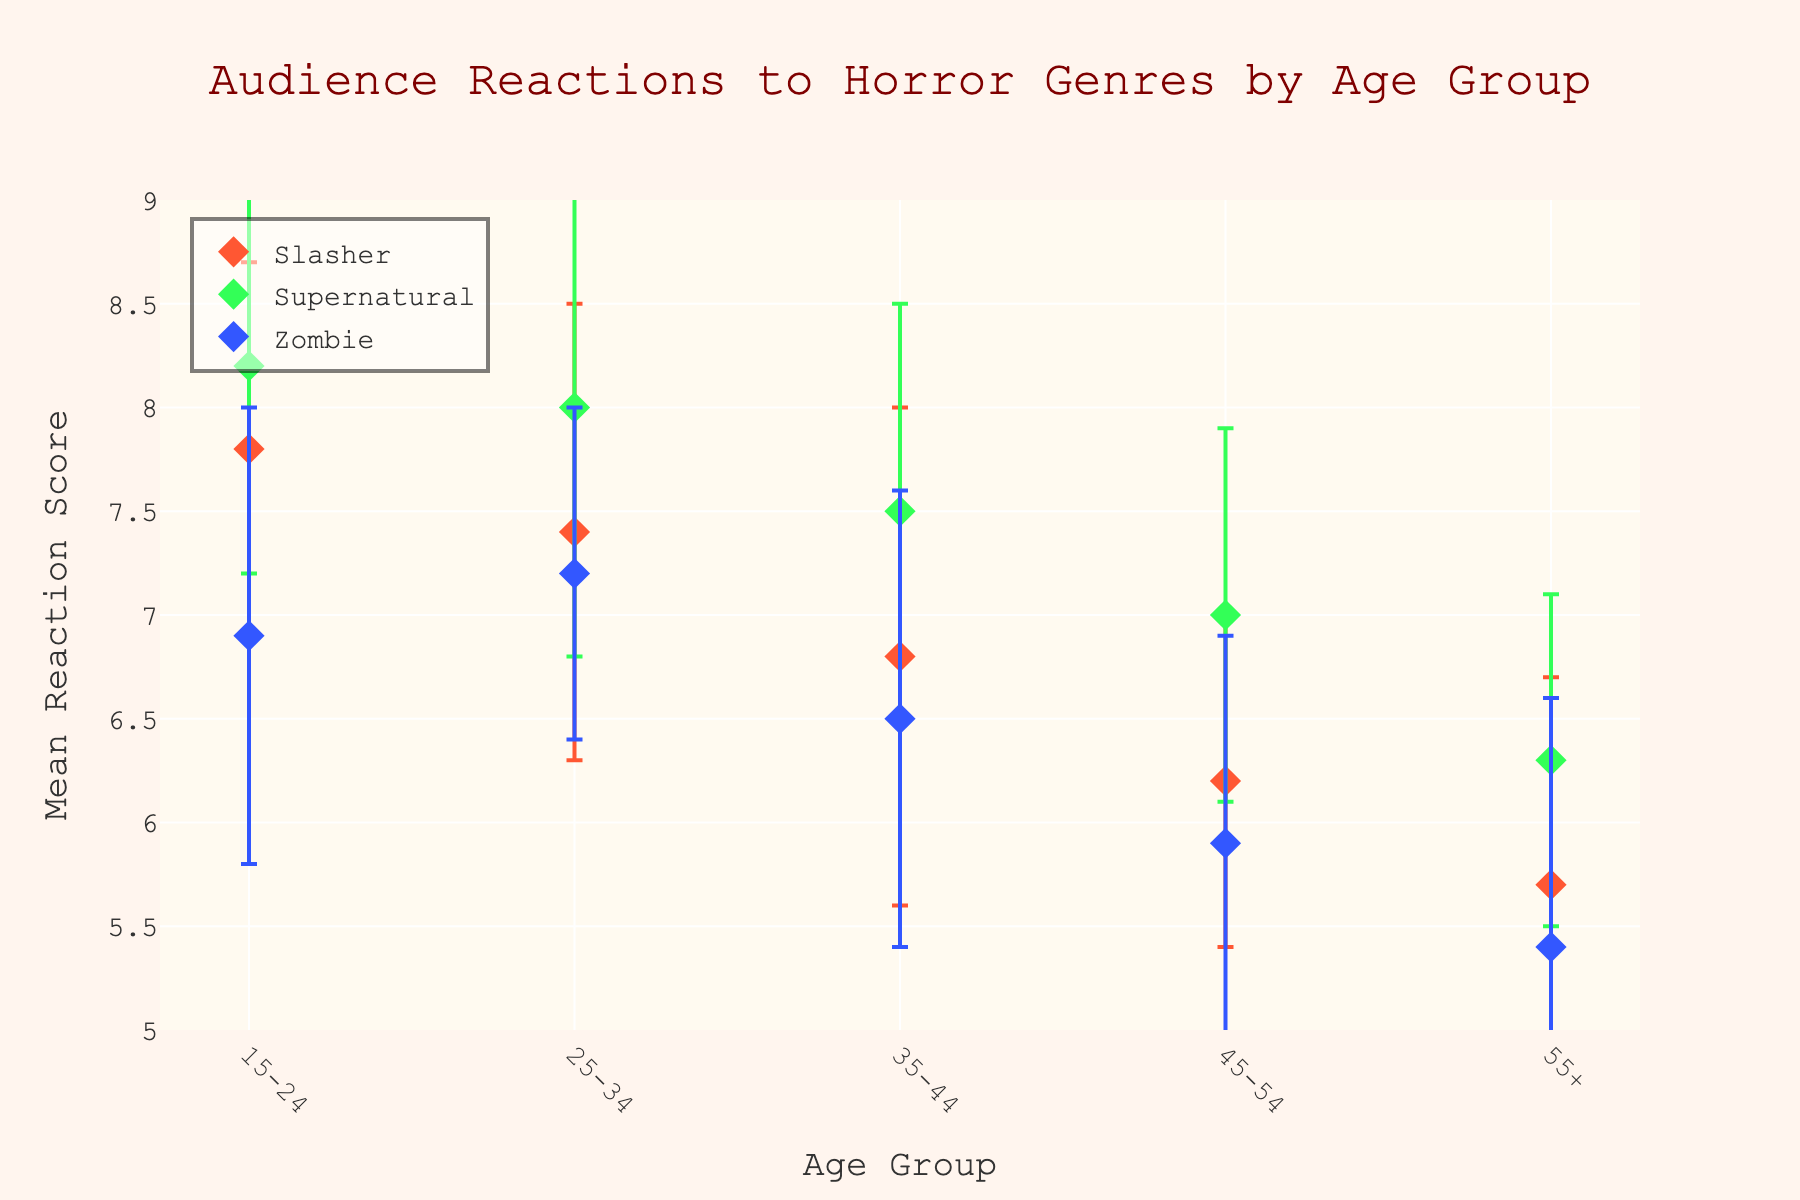Which age group shows the highest mean reaction to "Supernatural" horror films? The highest point for "Supernatural" is found for the age group 15-24.
Answer: 15-24 What is the mean reaction score for "Zombie" films in the 35-44 age group? Locate the "Zombie" dot for the 35-44 age group; it is positioned at 6.5 on the y-axis.
Answer: 6.5 How does the mean reaction for "Slasher" films differ between the 15-24 and 55+ age groups? Subtract the mean reaction of 55+ for "Slasher" (5.7) from that of the 15-24 age group (7.8): 7.8 - 5.7 = 2.1.
Answer: 2.1 Which horror subgenre has the most consistent reactions across all age groups? Look for the subgenre with the lowest overall error bars; "Supernatural" appears to have the smallest average error bars.
Answer: Supernatural Compare the mean reaction scores for "Supernatural" and "Zombie" genres in the 25-34 age group. Which genre has a higher mean reaction and by how much? "Supernatural" has a mean of 8.0 and "Zombie" has a mean of 7.2. 8.0 - 7.2 = 0.8.
Answer: Supernatural by 0.8 Are the reaction scores for "Slasher" films generally increasing or decreasing with age? By observing the "Slasher" dots across age groups, the scores decrease from 15-24 (7.8) to 55+ (5.7).
Answer: Decreasing What is the mean reaction score range for "Zombie" films among all age groups? The highest mean score for "Zombie" is 7.2 (25-34) and the lowest is 5.4 (55+); range = 7.2 - 5.4 = 1.8.
Answer: 1.8 Which age group shows the most variability in reactions to "Slasher" films? The largest error bar (standard deviation) for "Slasher" is found in the 35-44 age group.
Answer: 35-44 